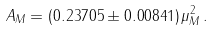<formula> <loc_0><loc_0><loc_500><loc_500>A _ { M } = ( 0 . 2 3 7 0 5 \pm 0 . 0 0 8 4 1 ) \, \mu _ { M } ^ { 2 } \, .</formula> 